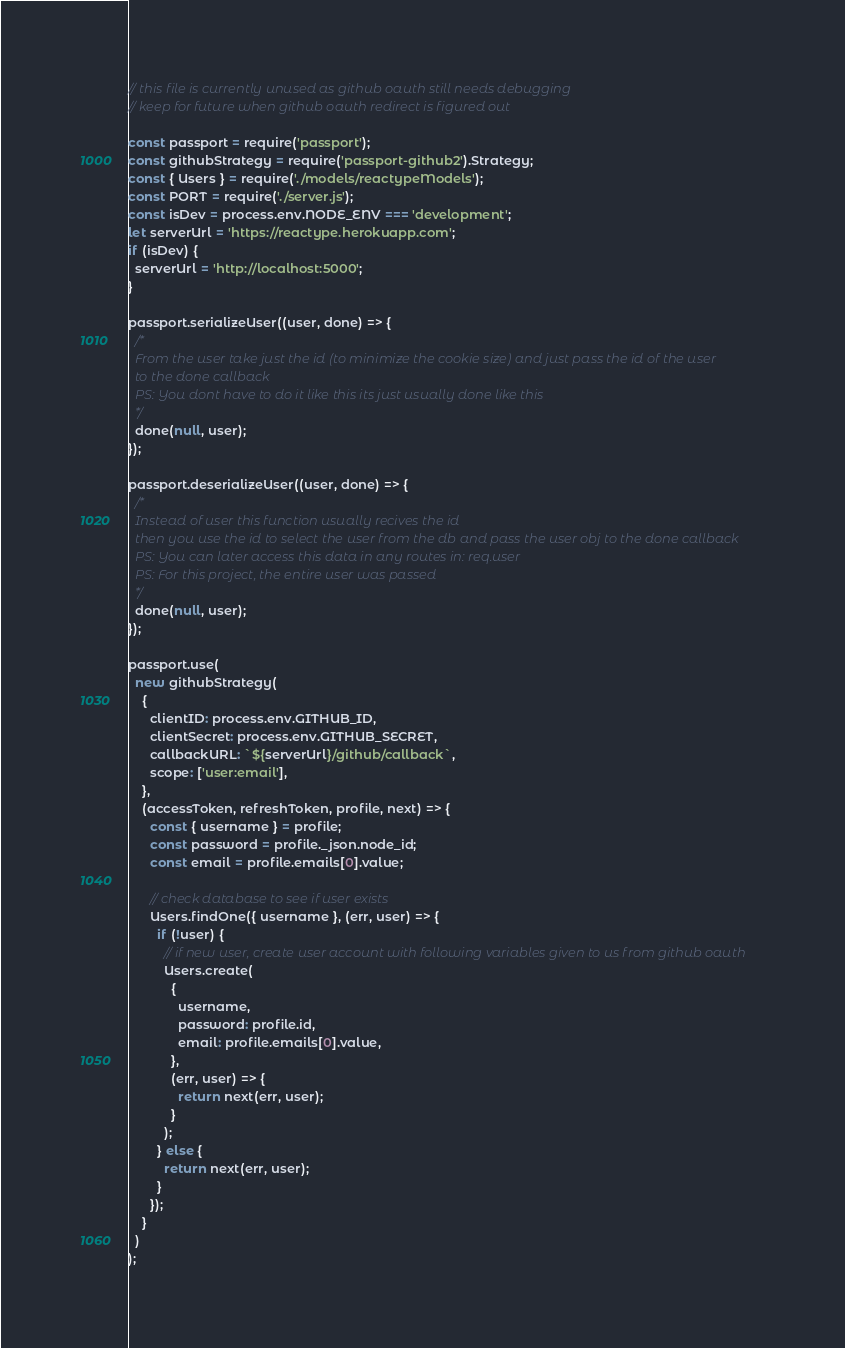Convert code to text. <code><loc_0><loc_0><loc_500><loc_500><_JavaScript_>// this file is currently unused as github oauth still needs debugging
// keep for future when github oauth redirect is figured out

const passport = require('passport');
const githubStrategy = require('passport-github2').Strategy;
const { Users } = require('./models/reactypeModels');
const PORT = require('./server.js');
const isDev = process.env.NODE_ENV === 'development';
let serverUrl = 'https://reactype.herokuapp.com';
if (isDev) {
  serverUrl = 'http://localhost:5000';
}

passport.serializeUser((user, done) => {
  /*
  From the user take just the id (to minimize the cookie size) and just pass the id of the user
  to the done callback
  PS: You dont have to do it like this its just usually done like this
  */
  done(null, user);
});

passport.deserializeUser((user, done) => {
  /*
  Instead of user this function usually recives the id
  then you use the id to select the user from the db and pass the user obj to the done callback
  PS: You can later access this data in any routes in: req.user
  PS: For this project, the entire user was passed
  */
  done(null, user);
});

passport.use(
  new githubStrategy(
    {
      clientID: process.env.GITHUB_ID,
      clientSecret: process.env.GITHUB_SECRET,
      callbackURL: `${serverUrl}/github/callback`,
      scope: ['user:email'],
    },
    (accessToken, refreshToken, profile, next) => {
      const { username } = profile;
      const password = profile._json.node_id;
      const email = profile.emails[0].value;

      // check database to see if user exists
      Users.findOne({ username }, (err, user) => {
        if (!user) {
          // if new user, create user account with following variables given to us from github oauth
          Users.create(
            {
              username,
              password: profile.id,
              email: profile.emails[0].value,
            },
            (err, user) => {
              return next(err, user);
            }
          );
        } else {
          return next(err, user);
        }
      });
    }
  )
);
</code> 